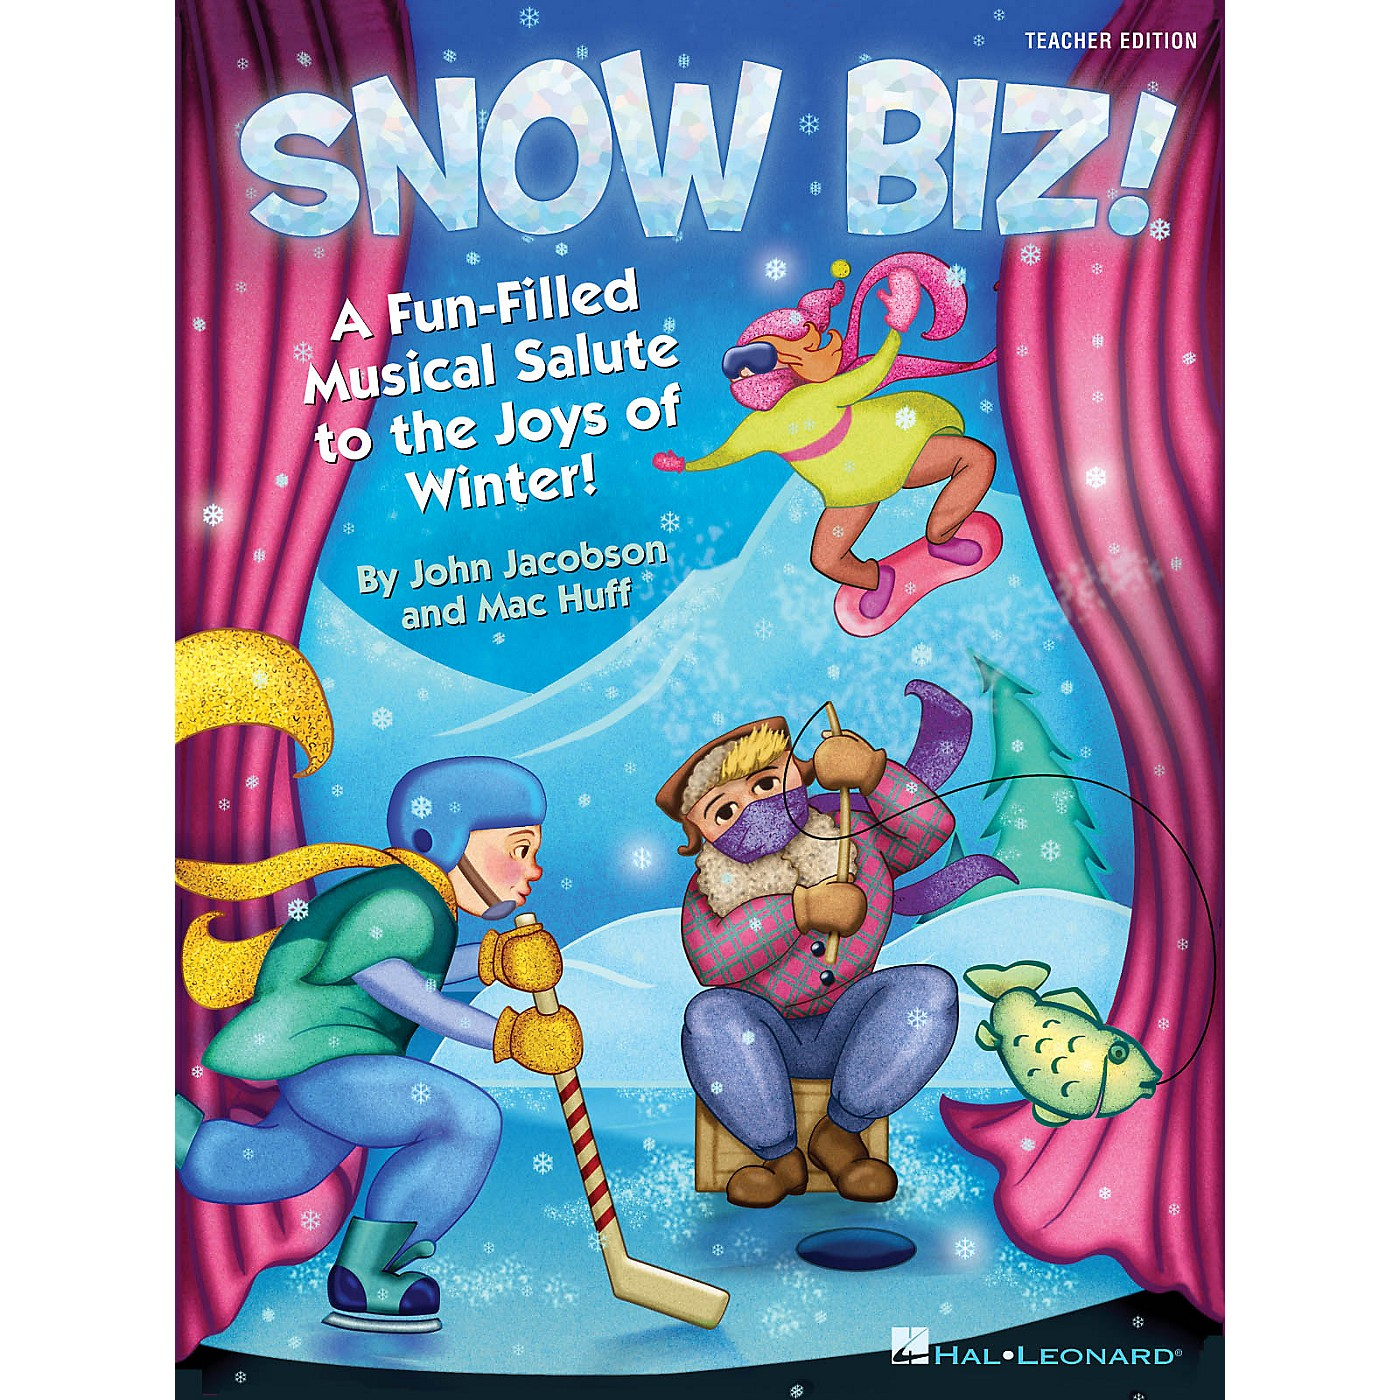The cover mentions it is a 'teacher edition.' What educational value might this material provide, and how could it be used in a classroom setting? As a 'teacher edition,' this material likely provides structured educational content designed to engage students in a fun and interactive way. It might include lesson plans, musical scores, and activities that teach not only about winter but also incorporate broader educational themes such as teamwork, creativity, and cultural traditions associated with the season. In a classroom setting, a teacher could use the material to orchestrate a winter musical performance, involving students in singing, dancing, and acting. It could also be used to teach students about different winter sports and activities, integrating physical education with the arts. By combining music, physical activity, and imaginative play, this educational tool could help students develop a wide range of skills, from literacy and numeracy to social and emotional learning, all while celebrating the joys of winter. 